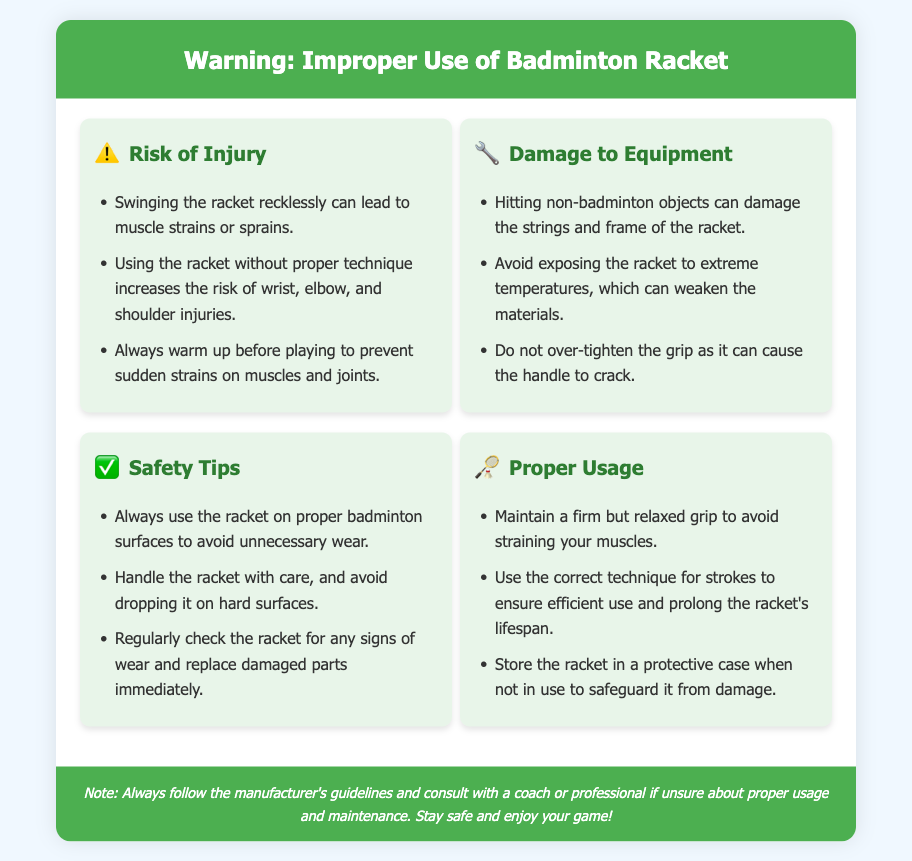what is the warning label about? The warning label is about the improper use of a badminton racket, detailing risks of injury and damage.
Answer: improper use of badminton racket what injury can occur from reckless swinging? The document states that swinging the racket recklessly can lead to muscle strains or sprains.
Answer: muscle strains or sprains what should be avoided to prevent equipment damage? Hitting non-badminton objects can damage the strings and frame of the racket.
Answer: hitting non-badminton objects how should the racket be stored when not in use? It should be stored in a protective case to safeguard it from damage.
Answer: protective case what is one of the safety tips provided? The document advises to handle the racket with care and avoid dropping it on hard surfaces.
Answer: handle with care how can one prolong the racket's lifespan? Using the correct technique for strokes ensures efficient use and prolongs the racket's lifespan.
Answer: correct technique for strokes what should be checked regularly to maintain safety? The document suggests regularly checking the racket for any signs of wear.
Answer: signs of wear what is indicated by the icon next to "Risk of Injury"? The icon next to "Risk of Injury" is a warning symbol indicating potential hazards.
Answer: ⚠️ how can extreme temperatures affect the racket? Extreme temperatures can weaken the materials of the racket.
Answer: weaken materials 